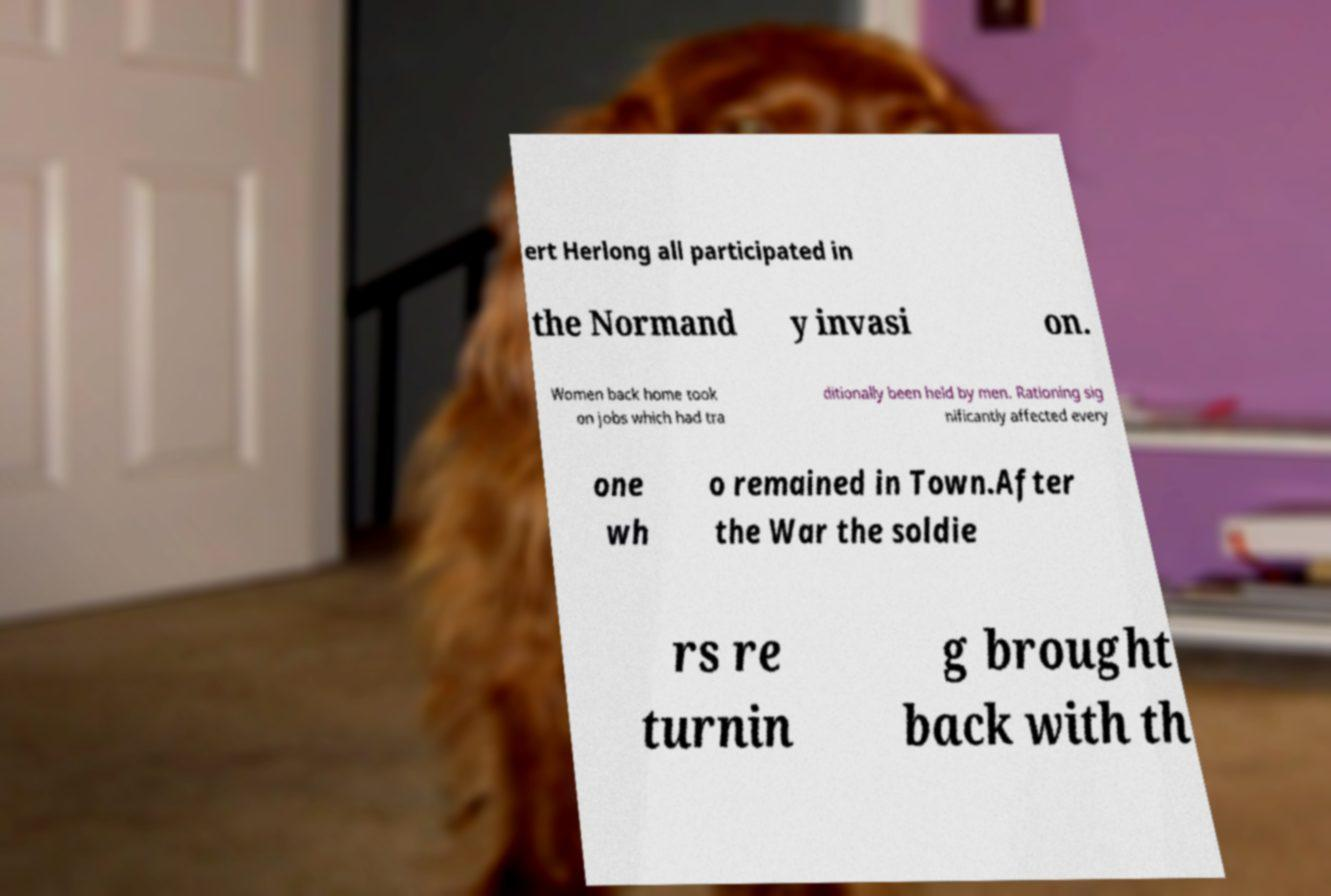Can you accurately transcribe the text from the provided image for me? ert Herlong all participated in the Normand y invasi on. Women back home took on jobs which had tra ditionally been held by men. Rationing sig nificantly affected every one wh o remained in Town.After the War the soldie rs re turnin g brought back with th 